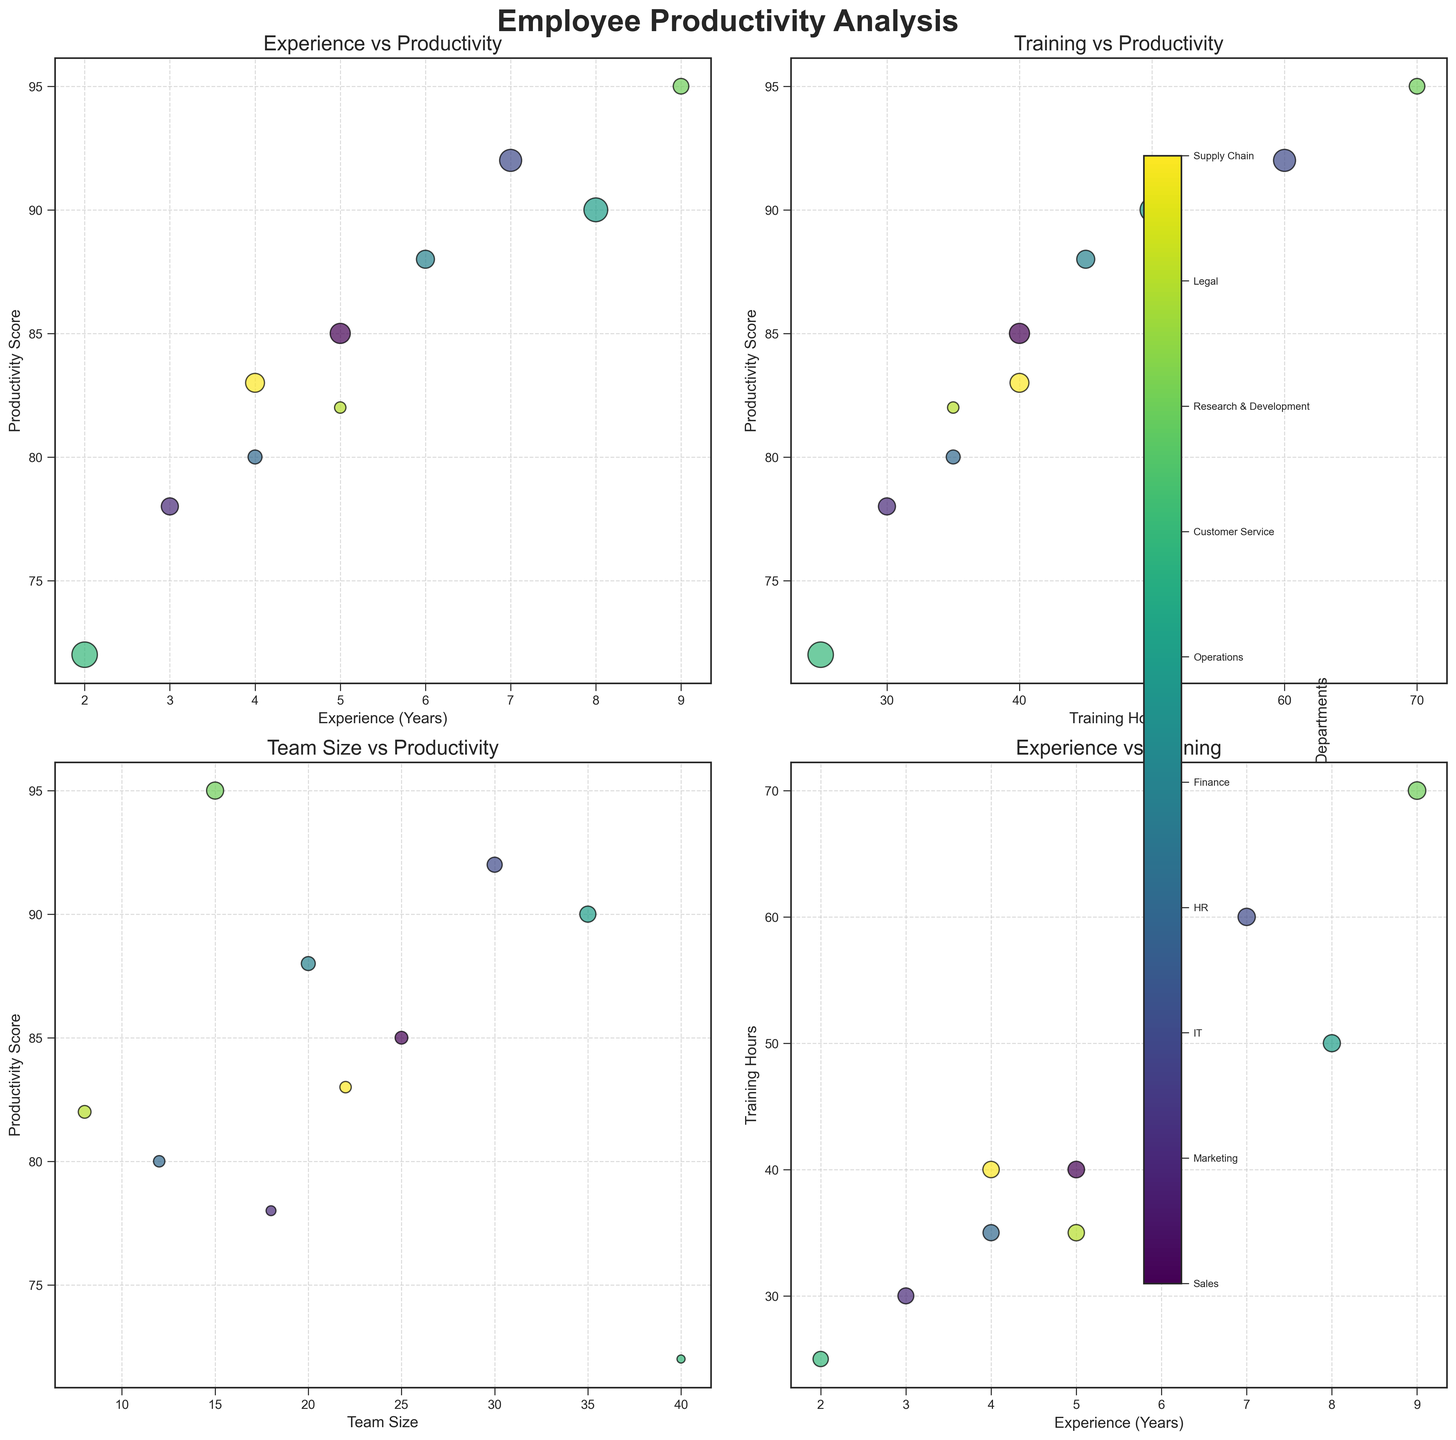What is the title of the subplot? The title is located at the center top of the figure and usually indicates what the figure is about. In this case, it is "Employee Productivity Analysis".
Answer: Employee Productivity Analysis What are the x and y axes labels in the plot of "Experience vs Productivity"? The x-axis label represents the horizontal axis, and the y-axis label represents the vertical axis. For "Experience vs Productivity," the x-axis label is "Experience (Years)" and the y-axis label is "Productivity Score".
Answer: Experience (Years) and Productivity Score Which department has the highest Productivity Score? By observing the plot, look for the highest point on the Productivity Score axis. The Research & Development department has the highest Productivity Score of 95.
Answer: Research & Development How does team size influence productivity in the subplot "Team Size vs Productivity"? Observe the plot to see if there's a pattern between team size and productivity. Generally, larger teams like Customer Service do not necessarily have the highest productivity. High productivity is achieved by moderately sized teams, like IT with a team size of 30 and a high productivity score.
Answer: Higher productivity often appears in moderately sized teams How is the size of the bubbles determined in the "Experience vs Training" plot? Look for the factors used to determine the bubble size. In the "Experience vs Training" plot, the bubble size is proportional to the Productivity Score. Larger bubbles indicate higher productivity scores.
Answer: Proportional to Productivity Score Which two departments have a productivity score close to 80 in the "Experience vs Productivity" plot? Identify bubbles in the "Experience vs Productivity" plot where the Productivity Score is around 80. HR and Legal departments have Productivity Scores close to 80 (80 and 82, respectively).
Answer: HR and Legal Compare the Training Hours and Productivity Score between IT and Finance in the "Training vs Productivity" plot. IT has 60 training hours and a productivity score of 92, while Finance has 45 training hours and a productivity score of 88. IT undergoes more training and has a higher productivity score compared to Finance.
Answer: IT: 60 hours, 92 score; Finance: 45 hours, 88 score Which department has the lowest Training Hours and what is their Productivity Score? In the plot of "Training vs Productivity," observe which bubble is furthest to the left for the Training Hours. The Customer Service department has the lowest training hours (25) and a Productivity Score of 72.
Answer: Customer Service, 72 Which subplot shows the relationship between experience and another factor? Check the subplot titles to identify which ones include "Experience". Both the "Experience vs Productivity" and "Experience vs Training" plots show relationships involving experience.
Answer: Experience vs Productivity and Experience vs Training Do higher team sizes generally correlate with higher productivity in the "Team Size vs Productivity" plot? Examine the trend in the plot. Larger team sizes like 40 do not show higher productivity compared to moderately sized teams. Thus, higher team sizes do not generally correlate with higher productivity.
Answer: No 